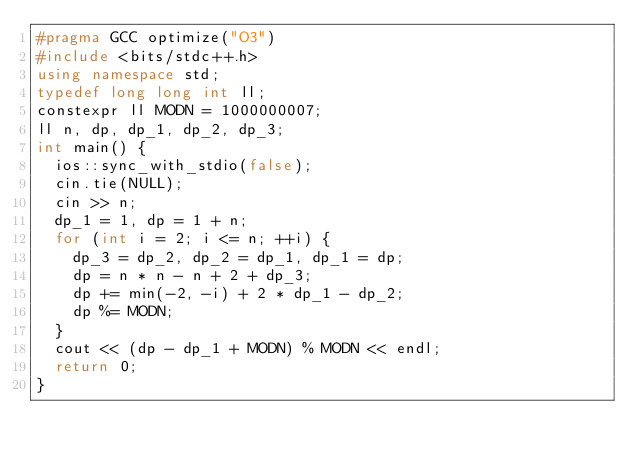Convert code to text. <code><loc_0><loc_0><loc_500><loc_500><_C++_>#pragma GCC optimize("O3")
#include <bits/stdc++.h>
using namespace std;
typedef long long int ll;
constexpr ll MODN = 1000000007;
ll n, dp, dp_1, dp_2, dp_3;
int main() {
	ios::sync_with_stdio(false);
	cin.tie(NULL);
	cin >> n;
	dp_1 = 1, dp = 1 + n;
	for (int i = 2; i <= n; ++i) {
		dp_3 = dp_2, dp_2 = dp_1, dp_1 = dp;
		dp = n * n - n + 2 + dp_3;
		dp += min(-2, -i) + 2 * dp_1 - dp_2;
		dp %= MODN;
	}
	cout << (dp - dp_1 + MODN) % MODN << endl;
	return 0;
}</code> 